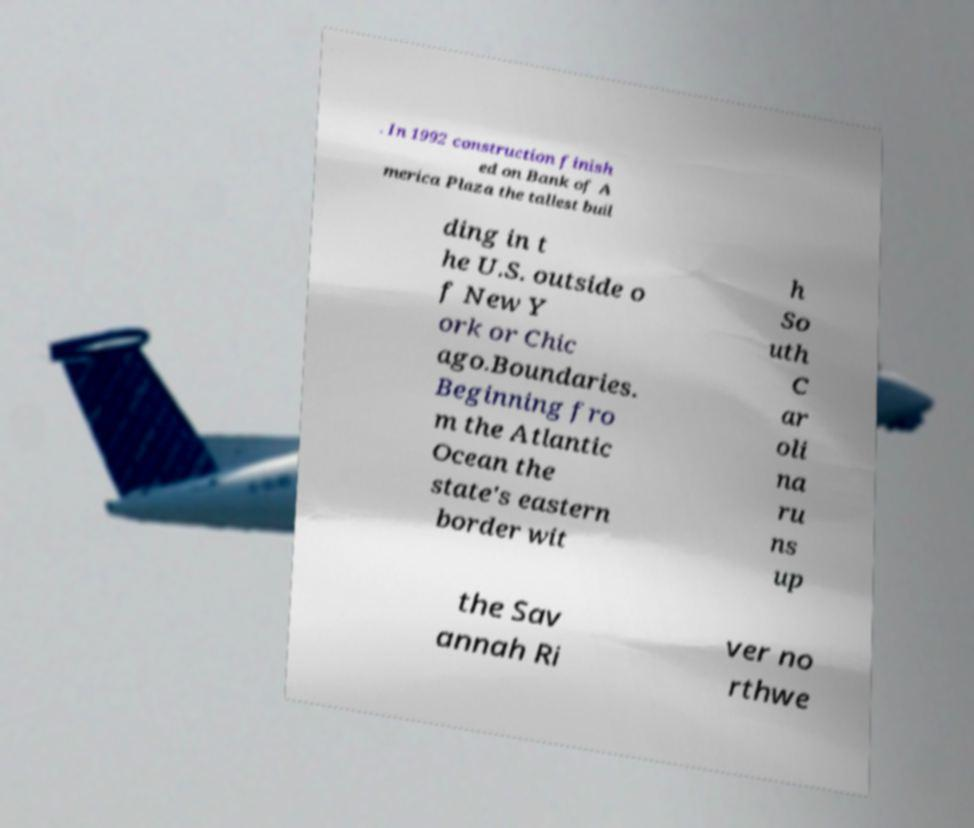Could you extract and type out the text from this image? . In 1992 construction finish ed on Bank of A merica Plaza the tallest buil ding in t he U.S. outside o f New Y ork or Chic ago.Boundaries. Beginning fro m the Atlantic Ocean the state's eastern border wit h So uth C ar oli na ru ns up the Sav annah Ri ver no rthwe 